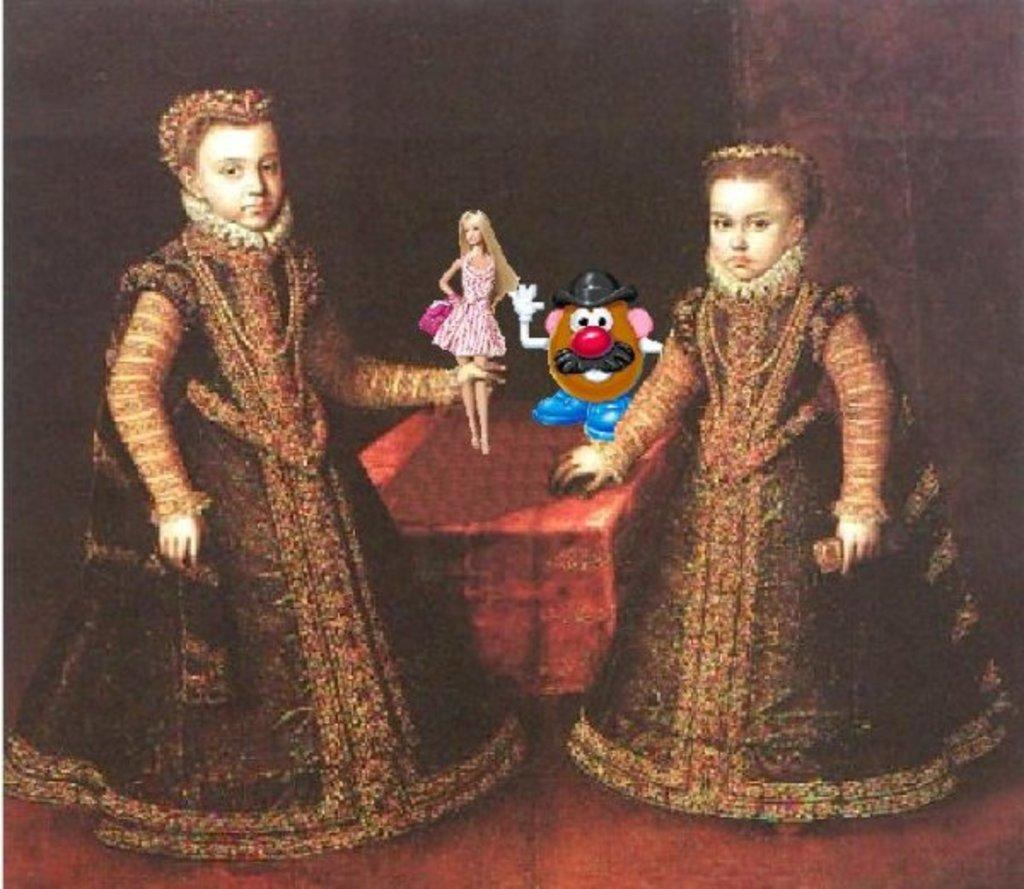How many people are in the image? There are two girls in the image. What are the girls doing in the image? The girls are standing in the image. What are the girls holding in their hands? The girls are holding objects in their hands. What can be seen in the background of the image? There are toys visible in the background of the image. What type of tree can be seen growing in the image? There is no tree present in the image. What process is the girls following to create a pancake in the image? There is no pancake or process visible in the image; the girls are simply standing and holding objects. 